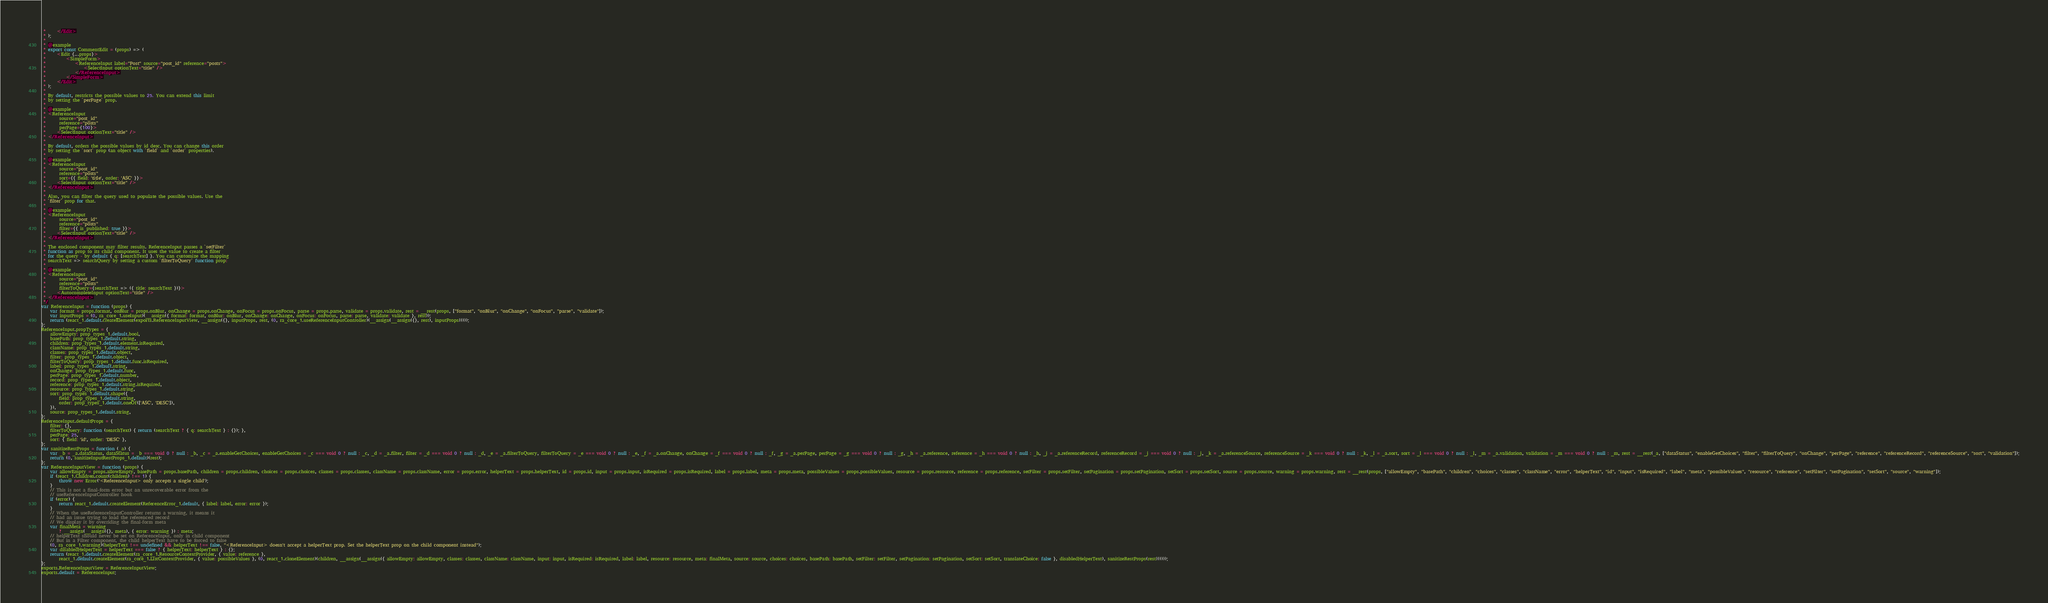<code> <loc_0><loc_0><loc_500><loc_500><_JavaScript_> *     </Edit>
 * );
 *
 * @example
 * export const CommentEdit = (props) => (
 *     <Edit {...props}>
 *         <SimpleForm>
 *             <ReferenceInput label="Post" source="post_id" reference="posts">
 *                 <SelectInput optionText="title" />
 *             </ReferenceInput>
 *         </SimpleForm>
 *     </Edit>
 * );
 *
 * By default, restricts the possible values to 25. You can extend this limit
 * by setting the `perPage` prop.
 *
 * @example
 * <ReferenceInput
 *      source="post_id"
 *      reference="posts"
 *      perPage={100}>
 *     <SelectInput optionText="title" />
 * </ReferenceInput>
 *
 * By default, orders the possible values by id desc. You can change this order
 * by setting the `sort` prop (an object with `field` and `order` properties).
 *
 * @example
 * <ReferenceInput
 *      source="post_id"
 *      reference="posts"
 *      sort={{ field: 'title', order: 'ASC' }}>
 *     <SelectInput optionText="title" />
 * </ReferenceInput>
 *
 * Also, you can filter the query used to populate the possible values. Use the
 * `filter` prop for that.
 *
 * @example
 * <ReferenceInput
 *      source="post_id"
 *      reference="posts"
 *      filter={{ is_published: true }}>
 *     <SelectInput optionText="title" />
 * </ReferenceInput>
 *
 * The enclosed component may filter results. ReferenceInput passes a `setFilter`
 * function as prop to its child component. It uses the value to create a filter
 * for the query - by default { q: [searchText] }. You can customize the mapping
 * searchText => searchQuery by setting a custom `filterToQuery` function prop:
 *
 * @example
 * <ReferenceInput
 *      source="post_id"
 *      reference="posts"
 *      filterToQuery={searchText => ({ title: searchText })}>
 *     <AutocompleteInput optionText="title" />
 * </ReferenceInput>
 */
var ReferenceInput = function (props) {
    var format = props.format, onBlur = props.onBlur, onChange = props.onChange, onFocus = props.onFocus, parse = props.parse, validate = props.validate, rest = __rest(props, ["format", "onBlur", "onChange", "onFocus", "parse", "validate"]);
    var inputProps = (0, ra_core_1.useInput)(__assign({ format: format, onBlur: onBlur, onChange: onChange, onFocus: onFocus, parse: parse, validate: validate }, rest));
    return (react_1.default.createElement(exports.ReferenceInputView, __assign({}, inputProps, rest, (0, ra_core_1.useReferenceInputController)(__assign(__assign({}, rest), inputProps)))));
};
ReferenceInput.propTypes = {
    allowEmpty: prop_types_1.default.bool,
    basePath: prop_types_1.default.string,
    children: prop_types_1.default.element.isRequired,
    className: prop_types_1.default.string,
    classes: prop_types_1.default.object,
    filter: prop_types_1.default.object,
    filterToQuery: prop_types_1.default.func.isRequired,
    label: prop_types_1.default.string,
    onChange: prop_types_1.default.func,
    perPage: prop_types_1.default.number,
    record: prop_types_1.default.object,
    reference: prop_types_1.default.string.isRequired,
    resource: prop_types_1.default.string,
    sort: prop_types_1.default.shape({
        field: prop_types_1.default.string,
        order: prop_types_1.default.oneOf(['ASC', 'DESC']),
    }),
    source: prop_types_1.default.string,
};
ReferenceInput.defaultProps = {
    filter: {},
    filterToQuery: function (searchText) { return (searchText ? { q: searchText } : {}); },
    perPage: 25,
    sort: { field: 'id', order: 'DESC' },
};
var sanitizeRestProps = function (_a) {
    var _b = _a.dataStatus, dataStatus = _b === void 0 ? null : _b, _c = _a.enableGetChoices, enableGetChoices = _c === void 0 ? null : _c, _d = _a.filter, filter = _d === void 0 ? null : _d, _e = _a.filterToQuery, filterToQuery = _e === void 0 ? null : _e, _f = _a.onChange, onChange = _f === void 0 ? null : _f, _g = _a.perPage, perPage = _g === void 0 ? null : _g, _h = _a.reference, reference = _h === void 0 ? null : _h, _j = _a.referenceRecord, referenceRecord = _j === void 0 ? null : _j, _k = _a.referenceSource, referenceSource = _k === void 0 ? null : _k, _l = _a.sort, sort = _l === void 0 ? null : _l, _m = _a.validation, validation = _m === void 0 ? null : _m, rest = __rest(_a, ["dataStatus", "enableGetChoices", "filter", "filterToQuery", "onChange", "perPage", "reference", "referenceRecord", "referenceSource", "sort", "validation"]);
    return (0, sanitizeInputRestProps_1.default)(rest);
};
var ReferenceInputView = function (props) {
    var allowEmpty = props.allowEmpty, basePath = props.basePath, children = props.children, choices = props.choices, classes = props.classes, className = props.className, error = props.error, helperText = props.helperText, id = props.id, input = props.input, isRequired = props.isRequired, label = props.label, meta = props.meta, possibleValues = props.possibleValues, resource = props.resource, reference = props.reference, setFilter = props.setFilter, setPagination = props.setPagination, setSort = props.setSort, source = props.source, warning = props.warning, rest = __rest(props, ["allowEmpty", "basePath", "children", "choices", "classes", "className", "error", "helperText", "id", "input", "isRequired", "label", "meta", "possibleValues", "resource", "reference", "setFilter", "setPagination", "setSort", "source", "warning"]);
    if (react_1.Children.count(children) !== 1) {
        throw new Error('<ReferenceInput> only accepts a single child');
    }
    // This is not a final-form error but an unrecoverable error from the
    // useReferenceInputController hook
    if (error) {
        return react_1.default.createElement(ReferenceError_1.default, { label: label, error: error });
    }
    // When the useReferenceInputController returns a warning, it means it
    // had an issue trying to load the referenced record
    // We display it by overriding the final-form meta
    var finalMeta = warning
        ? __assign(__assign({}, meta), { error: warning }) : meta;
    // helperText should never be set on ReferenceInput, only in child component
    // But in a Filter component, the child helperText have to be forced to false
    (0, ra_core_1.warning)(helperText !== undefined && helperText !== false, "<ReferenceInput> doesn't accept a helperText prop. Set the helperText prop on the child component instead");
    var disabledHelperText = helperText === false ? { helperText: helperText } : {};
    return (react_1.default.createElement(ra_core_1.ResourceContextProvider, { value: reference },
        react_1.default.createElement(ra_core_1.ListContextProvider, { value: possibleValues }, (0, react_1.cloneElement)(children, __assign(__assign({ allowEmpty: allowEmpty, classes: classes, className: className, input: input, isRequired: isRequired, label: label, resource: resource, meta: finalMeta, source: source, choices: choices, basePath: basePath, setFilter: setFilter, setPagination: setPagination, setSort: setSort, translateChoice: false }, disabledHelperText), sanitizeRestProps(rest))))));
};
exports.ReferenceInputView = ReferenceInputView;
exports.default = ReferenceInput;
</code> 